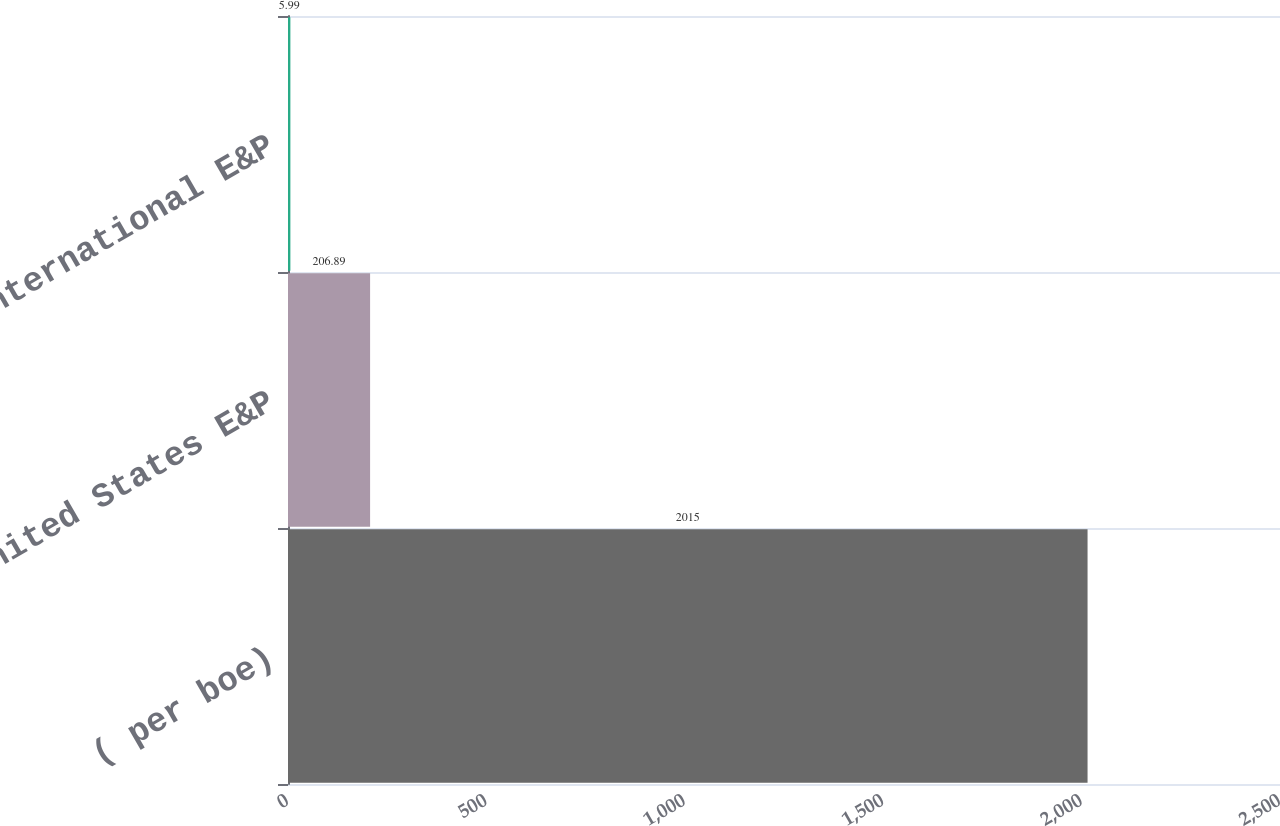Convert chart to OTSL. <chart><loc_0><loc_0><loc_500><loc_500><bar_chart><fcel>( per boe)<fcel>United States E&P<fcel>International E&P<nl><fcel>2015<fcel>206.89<fcel>5.99<nl></chart> 